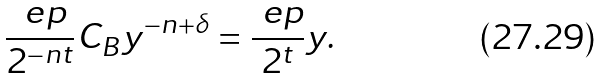<formula> <loc_0><loc_0><loc_500><loc_500>\frac { \ e p } { 2 ^ { - n t } } C _ { B } y ^ { - n + \delta } = \frac { \ e p } { 2 ^ { t } } y .</formula> 